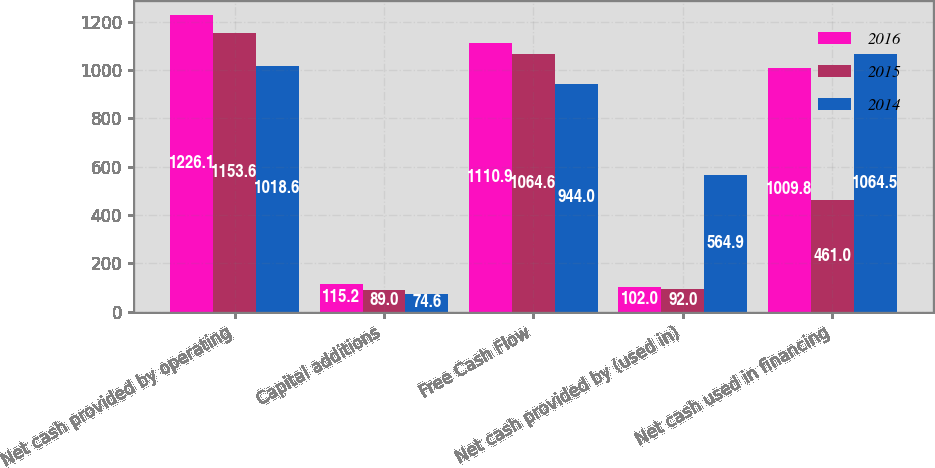Convert chart. <chart><loc_0><loc_0><loc_500><loc_500><stacked_bar_chart><ecel><fcel>Net cash provided by operating<fcel>Capital additions<fcel>Free Cash Flow<fcel>Net cash provided by (used in)<fcel>Net cash used in financing<nl><fcel>2016<fcel>1226.1<fcel>115.2<fcel>1110.9<fcel>102<fcel>1009.8<nl><fcel>2015<fcel>1153.6<fcel>89<fcel>1064.6<fcel>92<fcel>461<nl><fcel>2014<fcel>1018.6<fcel>74.6<fcel>944<fcel>564.9<fcel>1064.5<nl></chart> 